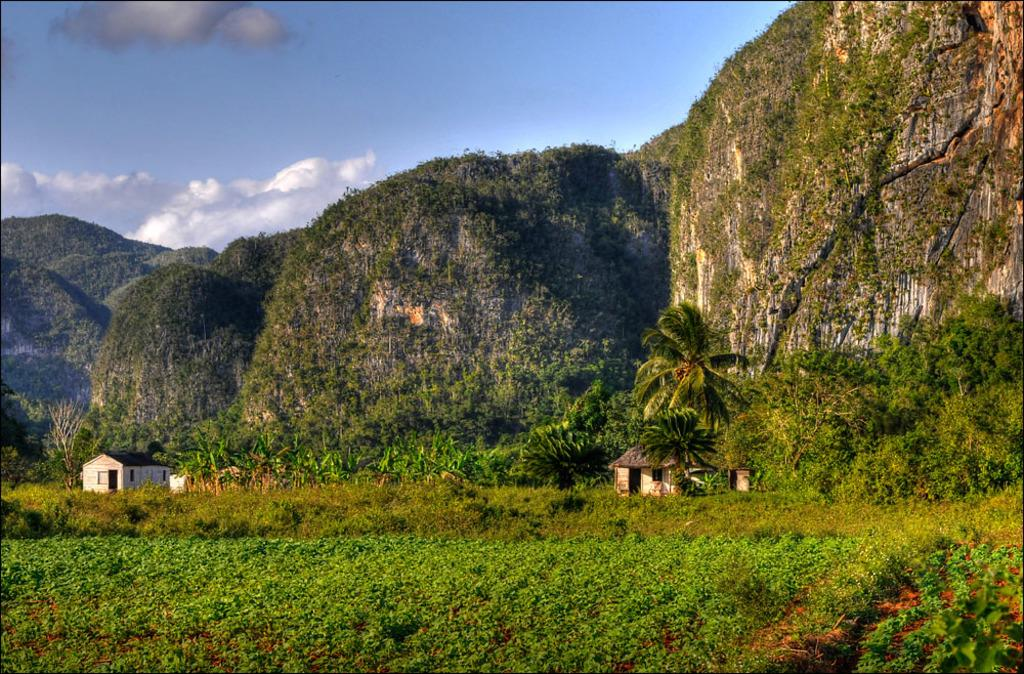What type of landscape is depicted in the image? The image shows hills covered with grass and plants. What structures can be seen in the center of the image? There are houses and trees in the center of the image. What type of vegetation is visible at the bottom of the image? Plants are visible at the bottom of the image. What invention is being demonstrated in the image? There is no invention being demonstrated in the image; it shows a landscape with hills, houses, trees, and plants. What type of air can be seen in the image? The image does not depict any specific type of air; it shows a landscape with natural elements. 